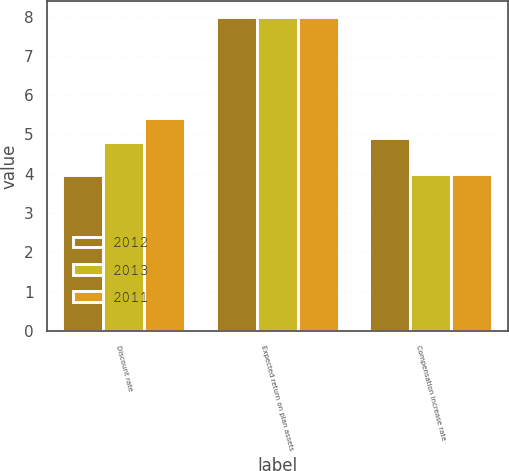<chart> <loc_0><loc_0><loc_500><loc_500><stacked_bar_chart><ecel><fcel>Discount rate<fcel>Expected return on plan assets<fcel>Compensation increase rate<nl><fcel>2012<fcel>3.97<fcel>8<fcel>4.91<nl><fcel>2013<fcel>4.82<fcel>8<fcel>4<nl><fcel>2011<fcel>5.42<fcel>8<fcel>4<nl></chart> 